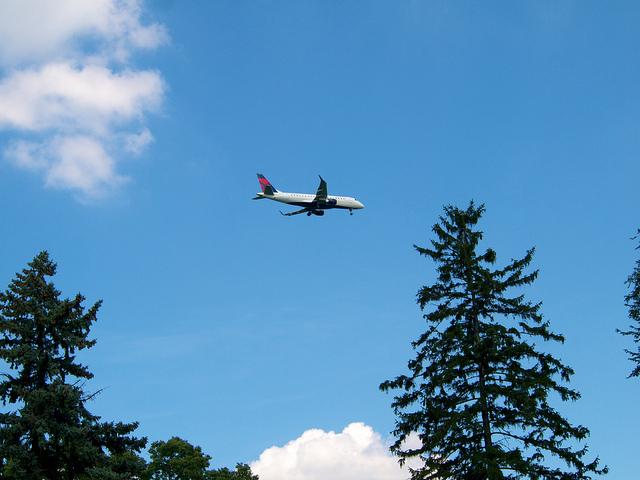What type of trees are these?
Keep it brief. Pine. Is the sky clear?
Concise answer only. Yes. Is this a military plane?
Concise answer only. No. What number of clouds are above the airplane?
Concise answer only. 1. How many planes are in the sky?
Be succinct. 1. Are there any clouds in the sky?
Quick response, please. Yes. Which is higher in the sky, the airplane or the clouds?
Short answer required. Clouds. Will the flight be smooth?
Write a very short answer. Yes. 